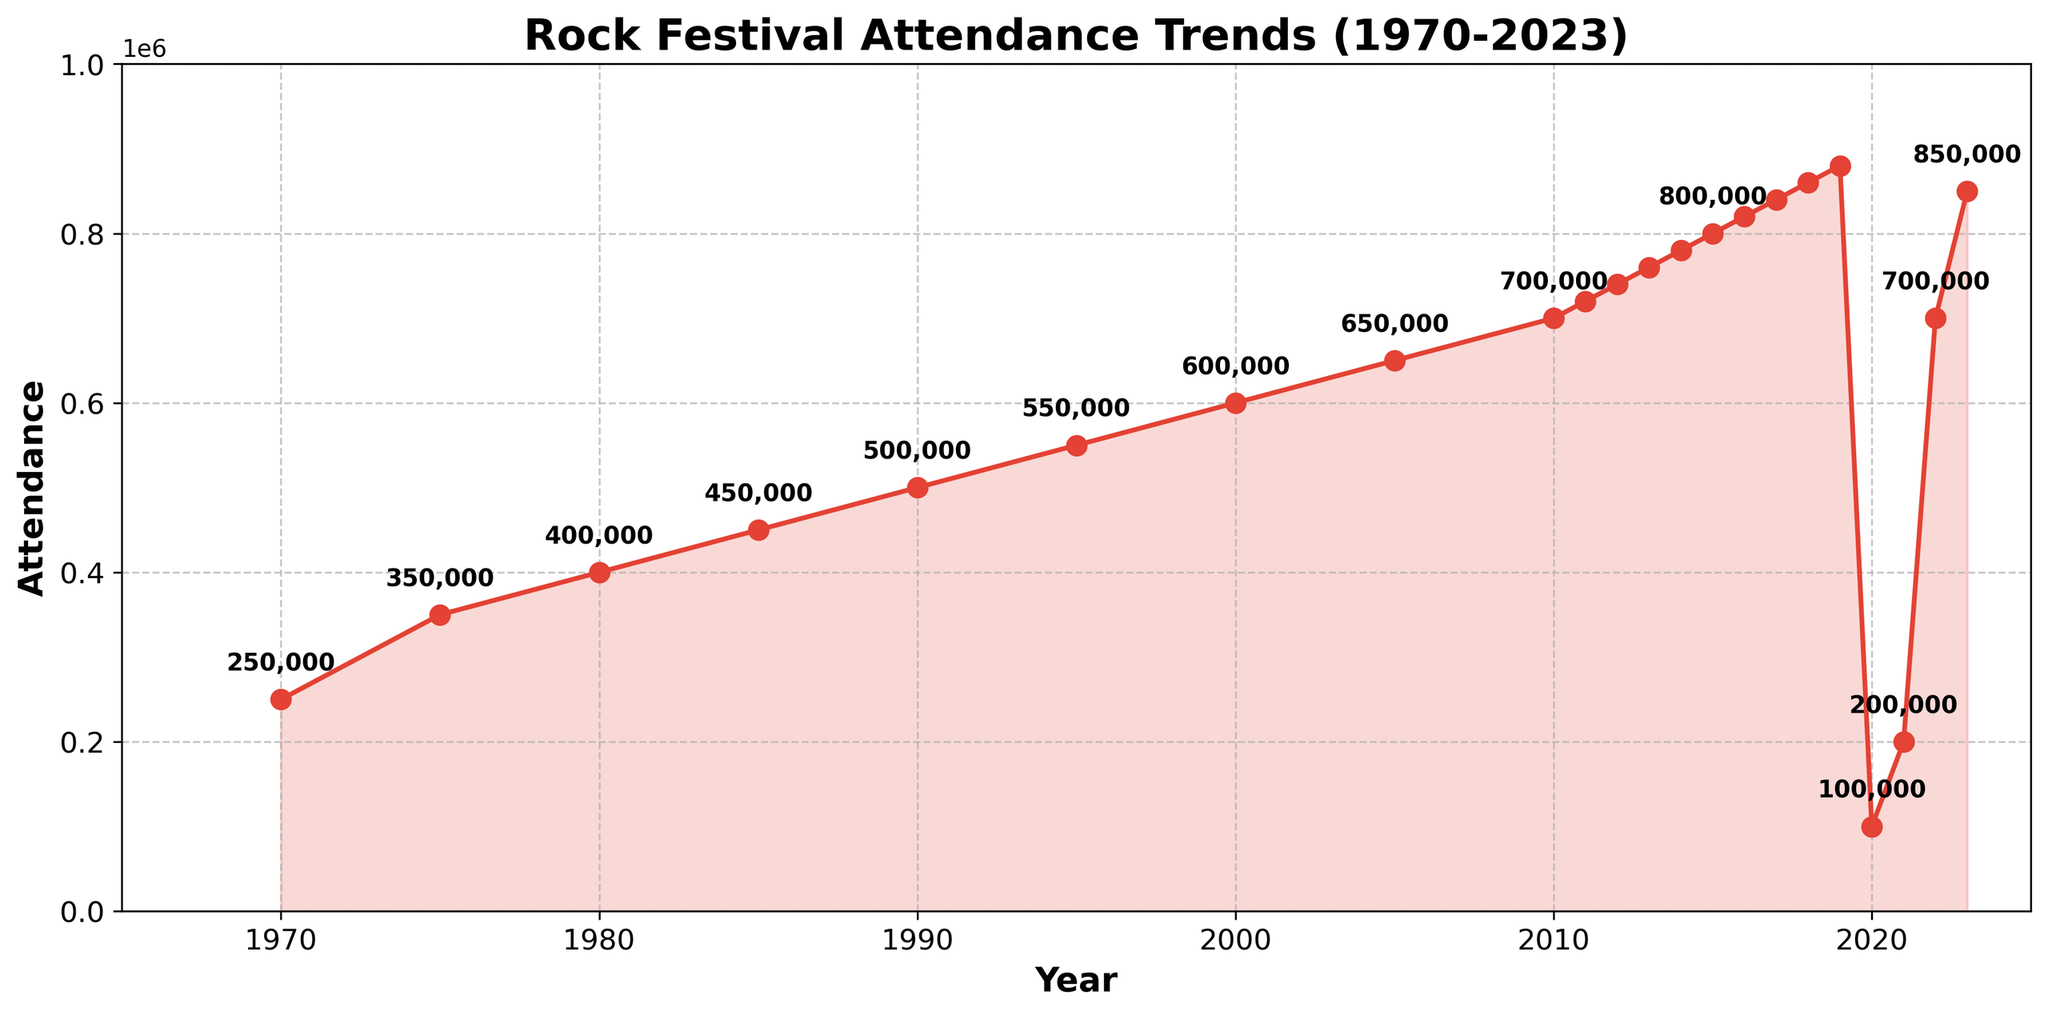What is the overall trend in attendance at rock festivals from 1970 to 2023? The trend line shows a general increase in attendance from 1970 to 2023, with a drop in 2020 and 2021, followed by a recovery in 2022 and 2023. This is visible by the upward slope of the line, especially after each decade mark, and the notable dips during the pandemic years.
Answer: Increasing, with a dip in 2020 and a recovery afterward Between which two consecutive years was the highest drop in attendance? By looking at the steepest decline in the line chart, the most significant drop happens between 2019 and 2020, where attendance falls from 880,000 to 100,000.
Answer: 2019-2020 How much did the attendance increase from 1970 to 2023? To find the increase, subtract the attendance in 1970 (250,000) from the attendance in 2023 (850,000). This gives 850,000 - 250,000 = 600,000.
Answer: 600,000 What was the attendance difference between 1990 and 2000? Subtract the attendance in 1990 (500,000) from the attendance in 2000 (600,000). This results in 600,000 - 500,000 = 100,000.
Answer: 100,000 Which year had the highest attendance since 1970? The highest point on the graph occurs in 2019, before the significant drop in 2020. 2019 has an attendance of 880,000.
Answer: 2019 In which years did the attendance remain nearly the same? The chart shows minimal growth between consecutive years for some periods, particularly from 2010 to 2011, 2011 to 2012, and so on up till 2019. However, the largest difference is observed in 2020 and 2021 with considerable increases afterward.
Answer: 2010-2019 (consistent small increases) What visual feature indicates the drop in attendance around 2020? The line on the chart drops drastically in 2020, and the filled area under the line also reduces sharply, visually indicating a significant decline in attendance.
Answer: Sharp drop in the line and reduced filled area What is the average annual attendance between 1970 and 2023? To calculate this, sum the attendance values for all years and divide by the number of years (54). Total attendance is 12,380,000, so 12,380,000 / 54 ≈ 229,259.
Answer: 229,259 During which decade did the most significant increase in attendance occur? By analyzing the chart's slope over each decade, the most substantial increase in attendance appears to be between 2010 and 2020.
Answer: 2010-2020 Compare the attendance growth from 1970-1990 and 2000-2020. Which period had higher growth? Calculate the attendance difference for each period: 
- 1970-1990: 500,000 - 250,000 = 250,000
- 2000-2020: 100,000 - 600,000 = -500,000
The growth was higher from 1970-1990.
Answer: 1970-1990 